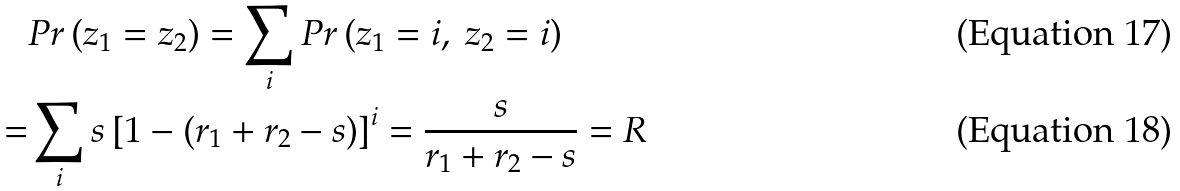Convert formula to latex. <formula><loc_0><loc_0><loc_500><loc_500>& P r \left ( z _ { 1 } = z _ { 2 } \right ) = \sum _ { i } P r \left ( z _ { 1 } = i , \ z _ { 2 } = i \right ) \\ = & \sum _ { i } s \left [ 1 - ( r _ { 1 } + r _ { 2 } - s ) \right ] ^ { i } = \frac { s } { r _ { 1 } + r _ { 2 } - s } = R</formula> 